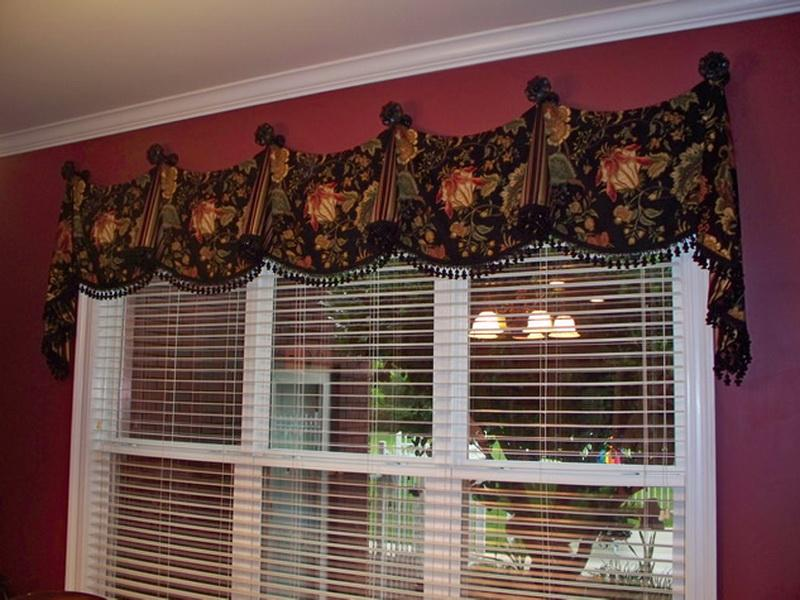Considering the design and style of the window treatment, what might be the overall aesthetic or theme of the room's decor, and how does the window treatment contribute to that aesthetic? Based on the window treatment's design and style, the overall aesthetic of the room's decor could be characterized as traditional with a touch of opulence. The floral pattern on the valance, along with the use of rich colors and tassel embellishments, suggests a preference for classic and somewhat ornate decor. The window treatment contributes to this aesthetic by serving as a focal point that complements the bold wall color, thereby reinforcing a sense of traditional elegance within the room. 